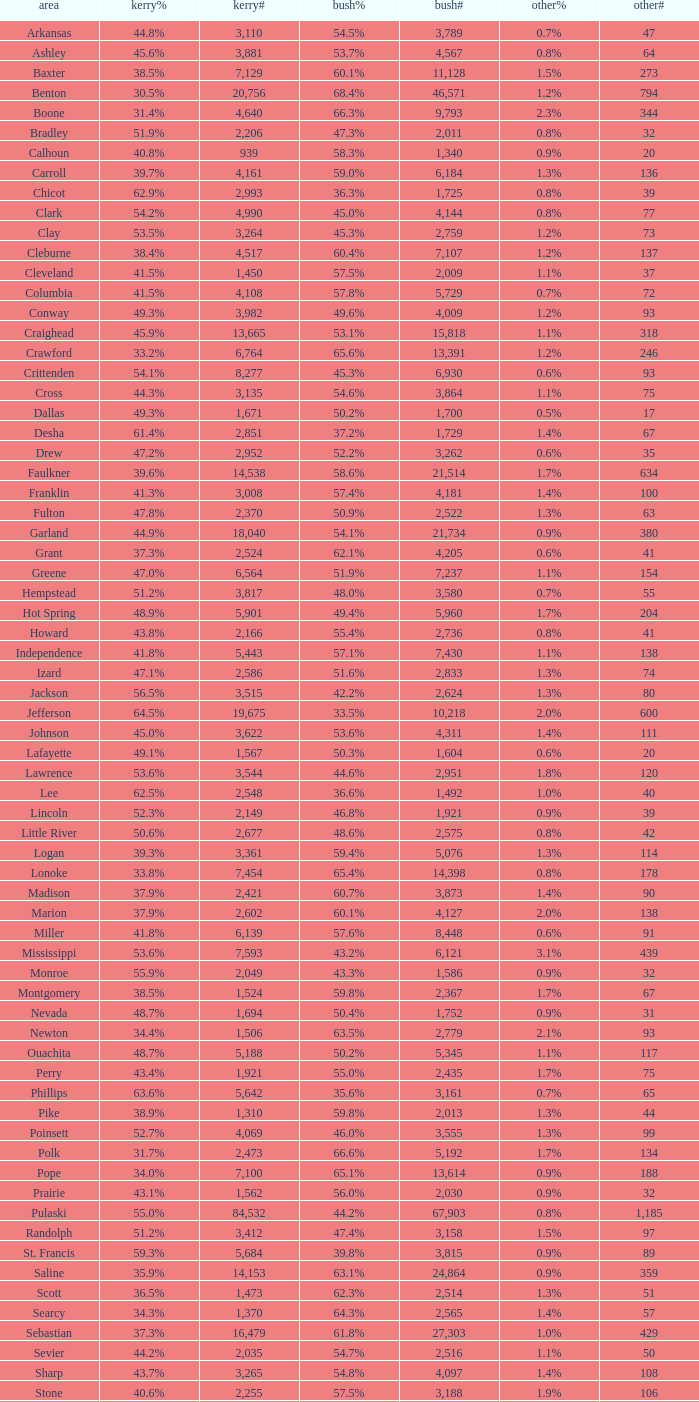7%", when others# is under 75, and when kerry# is more than 1,524? None. 